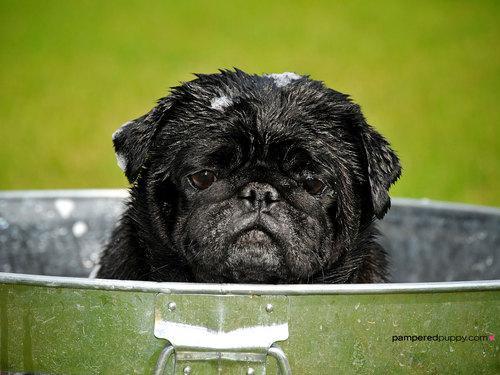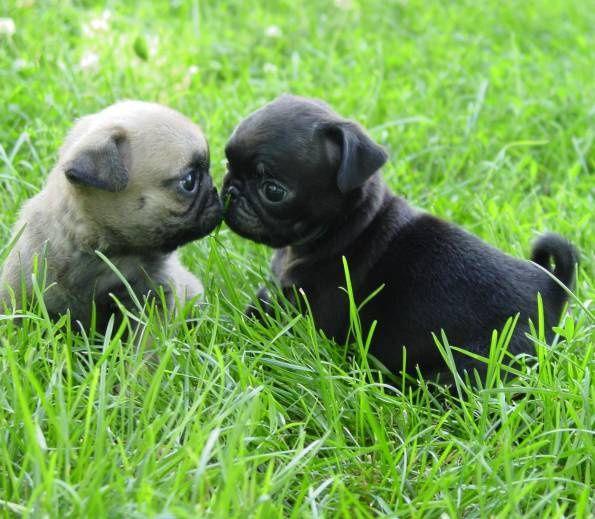The first image is the image on the left, the second image is the image on the right. Considering the images on both sides, is "An image features two different-colored pug dogs posing together in the grass." valid? Answer yes or no. Yes. 